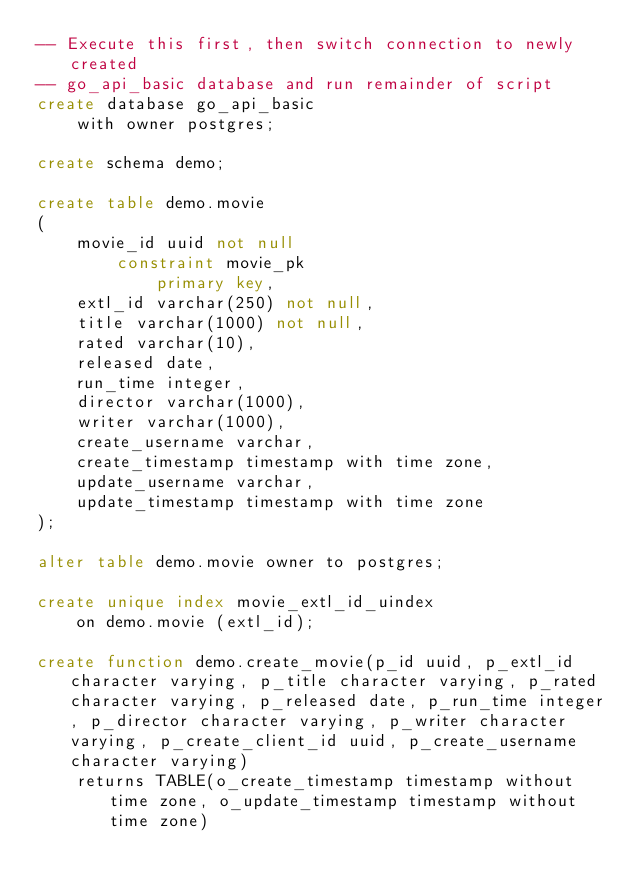<code> <loc_0><loc_0><loc_500><loc_500><_SQL_>-- Execute this first, then switch connection to newly created
-- go_api_basic database and run remainder of script
create database go_api_basic
    with owner postgres;

create schema demo;

create table demo.movie
(
    movie_id uuid not null
        constraint movie_pk
            primary key,
    extl_id varchar(250) not null,
    title varchar(1000) not null,
    rated varchar(10),
    released date,
    run_time integer,
    director varchar(1000),
    writer varchar(1000),
    create_username varchar,
    create_timestamp timestamp with time zone,
    update_username varchar,
    update_timestamp timestamp with time zone
);

alter table demo.movie owner to postgres;

create unique index movie_extl_id_uindex
    on demo.movie (extl_id);

create function demo.create_movie(p_id uuid, p_extl_id character varying, p_title character varying, p_rated character varying, p_released date, p_run_time integer, p_director character varying, p_writer character varying, p_create_client_id uuid, p_create_username character varying)
    returns TABLE(o_create_timestamp timestamp without time zone, o_update_timestamp timestamp without time zone)</code> 